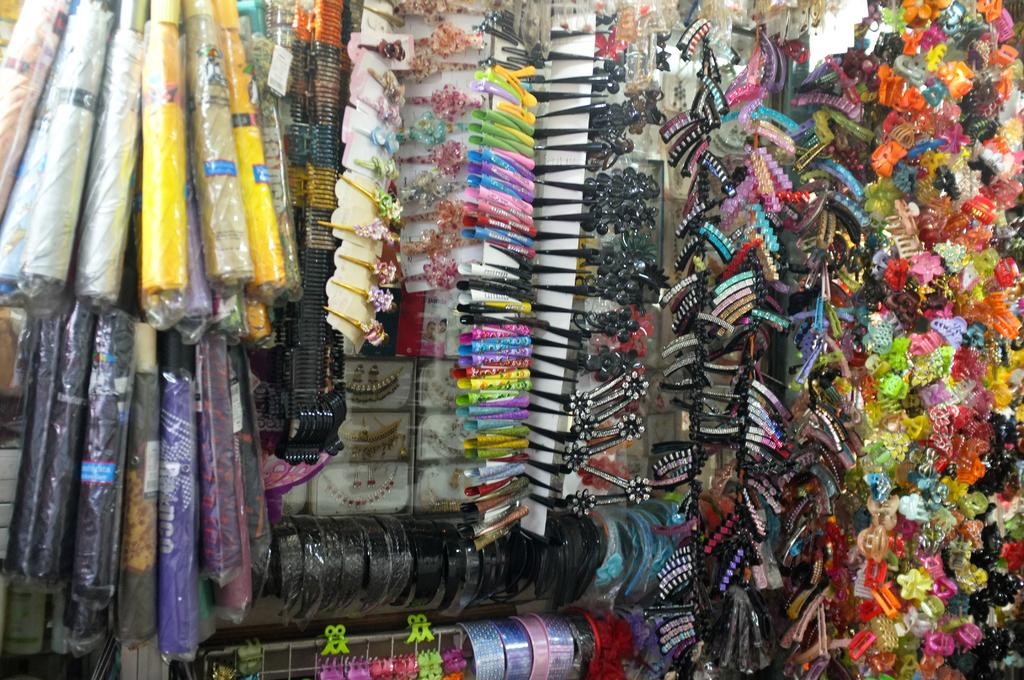What types of items are present in the image? There are many accessories and umbrellas in the image. Can you describe the appearance of the accessories and umbrellas? The accessories and umbrellas are colorful. How many apples can be seen on the umbrellas in the image? There are no apples present on the umbrellas in the image. What direction are the horses pointing in the image? There are no horses present in the image. 